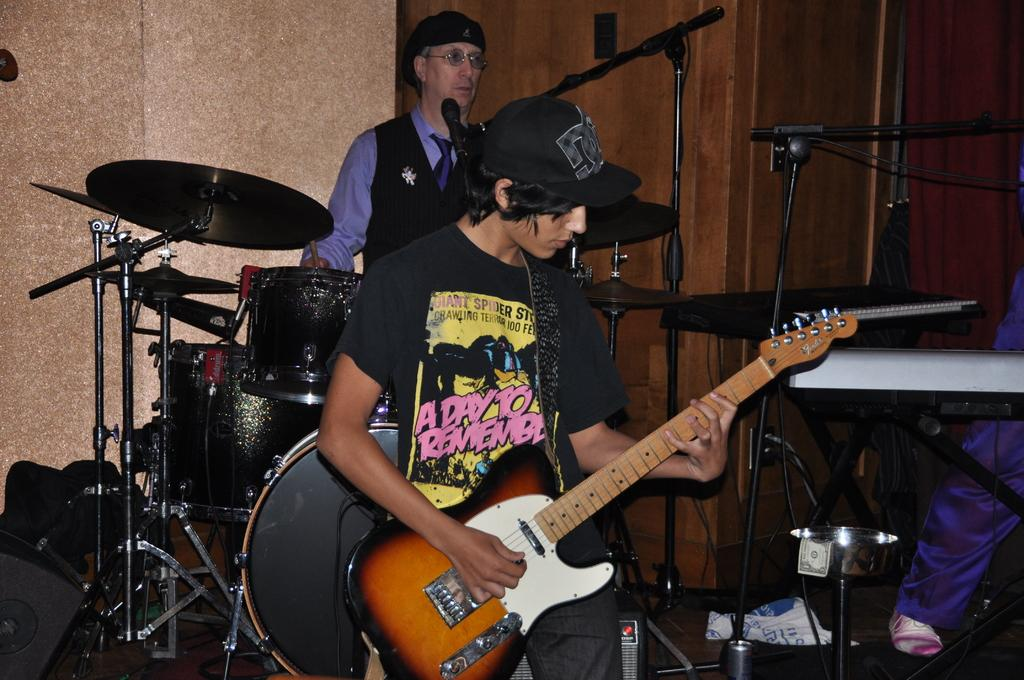How many people are in the image? There are three persons in the image. What are the persons doing in the image? The persons are standing and playing musical instruments. What are the persons wearing on their heads? The persons are wearing caps. What can be seen in the background of the image? There is a cupboard, a wall, and musical instruments in the background of the image. Are there any fairies playing musical instruments in the image? No, there are no fairies present in the image. What type of blade is being used by the persons in the image? There is no blade visible in the image; the persons are playing musical instruments. 